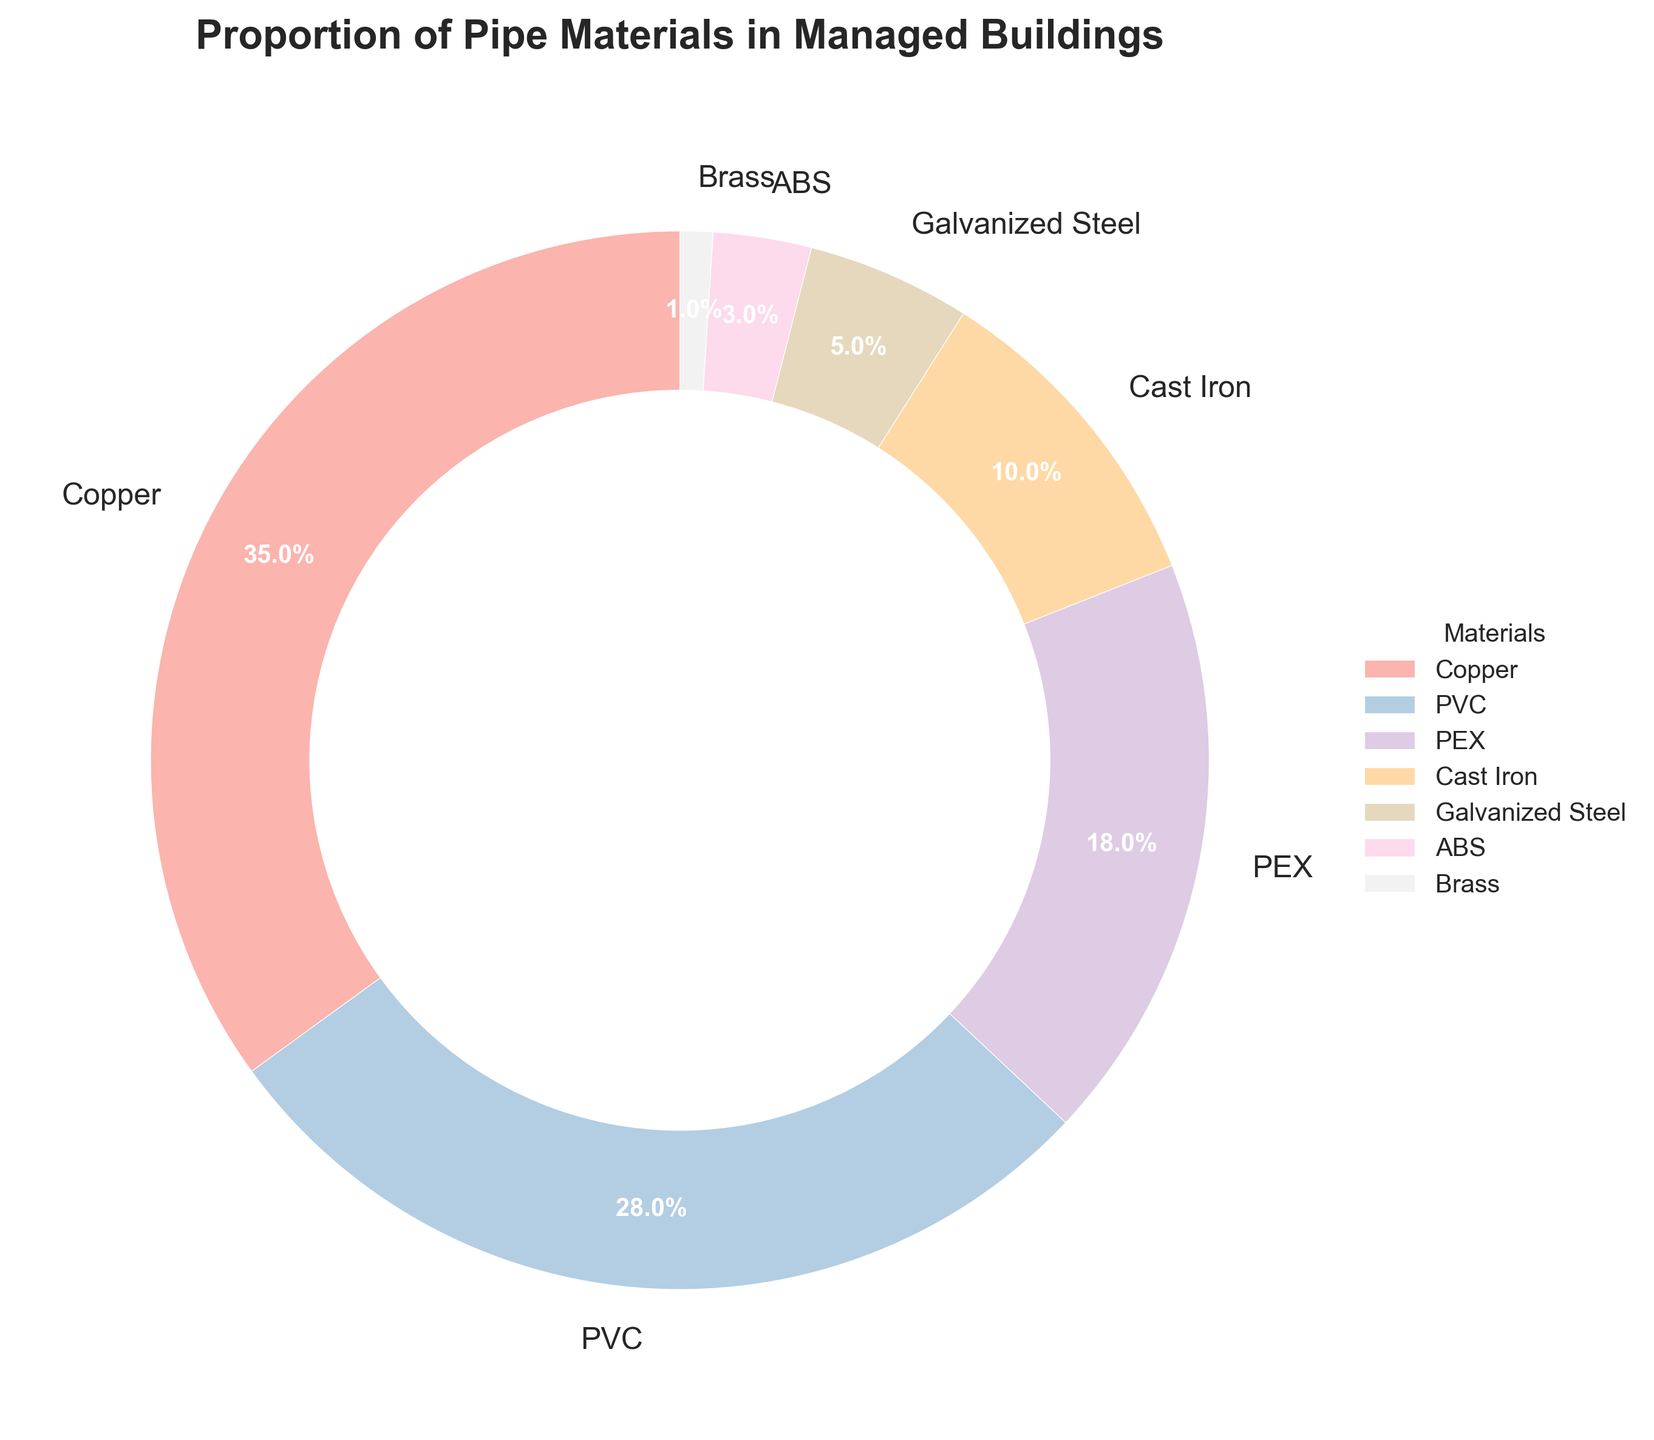What is the most common pipe material used in managed buildings? Look at the chart and identify the segment with the largest proportion. Copper is the material with the largest segment, making up 35% of the total.
Answer: Copper Which pipe material has nearly the same proportion as PVC? Identify the sections with similar sizes to the PVC segment. PVC has 28% and the closest in proportion is PEX at 18%.
Answer: PEX How much more common is Copper compared to Galvanized Steel? Observe the proportions of Copper and Galvanized Steel in the chart. Copper is 35%, and Galvanized Steel is 5%. The difference is 35% - 5% = 30%.
Answer: 30% What is the combined percentage of PEX and ABS pipe materials? Add the proportions of PEX (18%) and ABS (3%). 18% + 3% = 21%.
Answer: 21% Which material has the smallest representation in managed buildings, and what is its percentage? Look for the segment with the smallest size in the chart. Brass has the smallest segment at 1%.
Answer: Brass, 1% Are Cast Iron pipes more common than Galvanized Steel pipes? Compare the percentages of Cast Iron and Galvanized Steel segments. Cast Iron is 10%, and Galvanized Steel is 5%. Cast Iron is more common.
Answer: Yes What is the total percentage of Copper, PVC, and PEX pipe materials combined? Add the percentages of Copper (35%), PVC (28%), and PEX (18%). 35% + 28% + 18% = 81%.
Answer: 81% Which material(s) have a percentage less than 10%? Identify segments with proportions below 10%. Cast Iron (10%), Galvanized Steel (5%), ABS (3%), and Brass (1%) are the materials below 10%.
Answer: Galvanized Steel, ABS, Brass Compare the combined usage of Cast Iron and Galvanized Steel to PVC. Are they used more or less frequently together than PVC alone? Add the percentages of Cast Iron (10%) and Galvanized Steel (5%) and compare the sum to PVC (28%). 10% + 5% = 15%, which is less than 28%.
Answer: Less What is the overall percentage of all materials other than Copper? Subtract the percentage of Copper from 100%. 100% - 35% = 65%.
Answer: 65% 